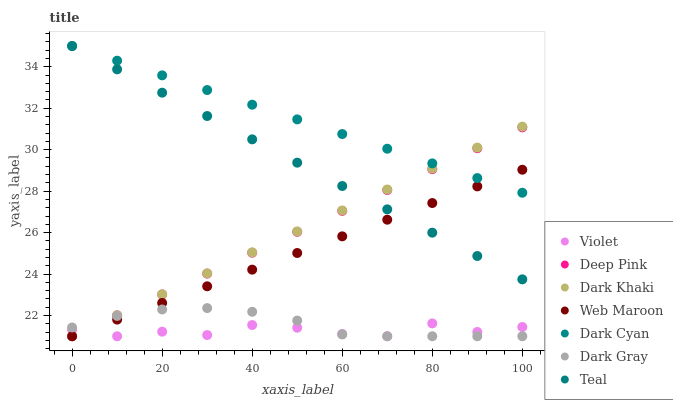Does Violet have the minimum area under the curve?
Answer yes or no. Yes. Does Dark Cyan have the maximum area under the curve?
Answer yes or no. Yes. Does Deep Pink have the minimum area under the curve?
Answer yes or no. No. Does Deep Pink have the maximum area under the curve?
Answer yes or no. No. Is Dark Khaki the smoothest?
Answer yes or no. Yes. Is Violet the roughest?
Answer yes or no. Yes. Is Deep Pink the smoothest?
Answer yes or no. No. Is Deep Pink the roughest?
Answer yes or no. No. Does Dark Gray have the lowest value?
Answer yes or no. Yes. Does Teal have the lowest value?
Answer yes or no. No. Does Dark Cyan have the highest value?
Answer yes or no. Yes. Does Deep Pink have the highest value?
Answer yes or no. No. Is Dark Gray less than Teal?
Answer yes or no. Yes. Is Dark Cyan greater than Violet?
Answer yes or no. Yes. Does Deep Pink intersect Dark Cyan?
Answer yes or no. Yes. Is Deep Pink less than Dark Cyan?
Answer yes or no. No. Is Deep Pink greater than Dark Cyan?
Answer yes or no. No. Does Dark Gray intersect Teal?
Answer yes or no. No. 